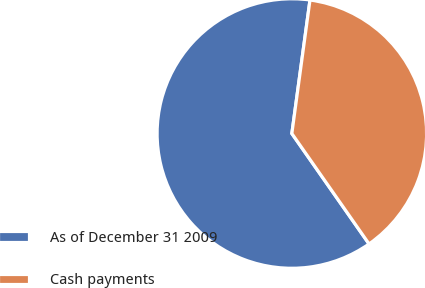Convert chart. <chart><loc_0><loc_0><loc_500><loc_500><pie_chart><fcel>As of December 31 2009<fcel>Cash payments<nl><fcel>61.86%<fcel>38.14%<nl></chart> 